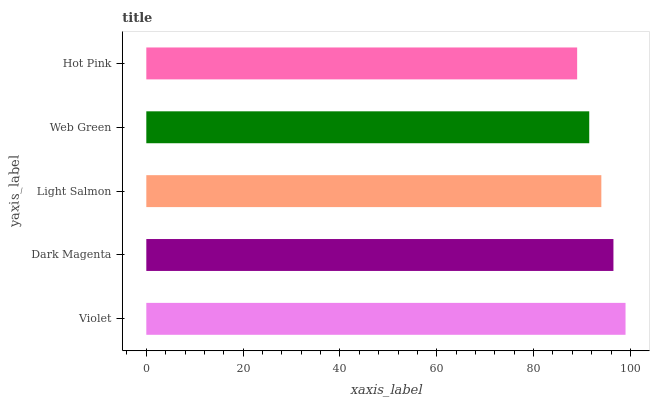Is Hot Pink the minimum?
Answer yes or no. Yes. Is Violet the maximum?
Answer yes or no. Yes. Is Dark Magenta the minimum?
Answer yes or no. No. Is Dark Magenta the maximum?
Answer yes or no. No. Is Violet greater than Dark Magenta?
Answer yes or no. Yes. Is Dark Magenta less than Violet?
Answer yes or no. Yes. Is Dark Magenta greater than Violet?
Answer yes or no. No. Is Violet less than Dark Magenta?
Answer yes or no. No. Is Light Salmon the high median?
Answer yes or no. Yes. Is Light Salmon the low median?
Answer yes or no. Yes. Is Dark Magenta the high median?
Answer yes or no. No. Is Hot Pink the low median?
Answer yes or no. No. 